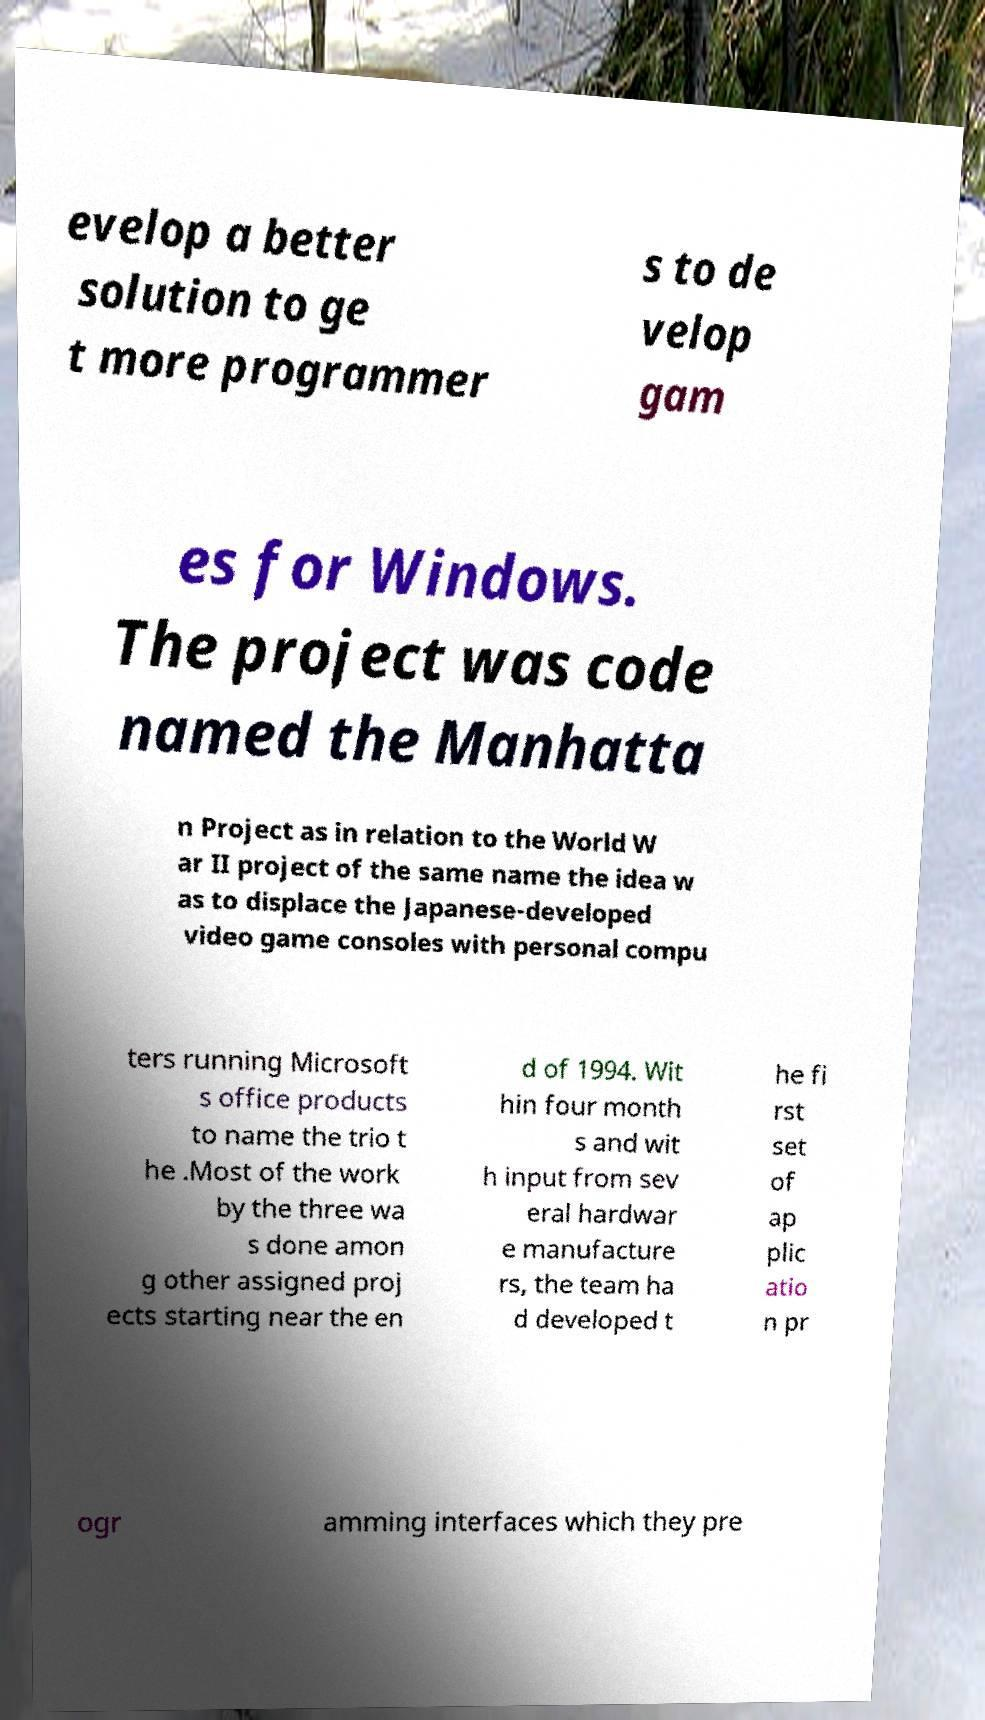Can you accurately transcribe the text from the provided image for me? evelop a better solution to ge t more programmer s to de velop gam es for Windows. The project was code named the Manhatta n Project as in relation to the World W ar II project of the same name the idea w as to displace the Japanese-developed video game consoles with personal compu ters running Microsoft s office products to name the trio t he .Most of the work by the three wa s done amon g other assigned proj ects starting near the en d of 1994. Wit hin four month s and wit h input from sev eral hardwar e manufacture rs, the team ha d developed t he fi rst set of ap plic atio n pr ogr amming interfaces which they pre 